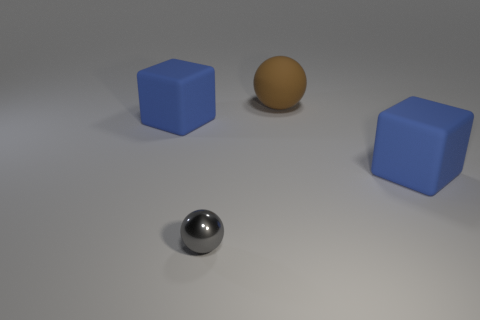How many other objects are the same size as the shiny object?
Provide a succinct answer. 0. What number of objects are either big matte objects that are behind the metallic sphere or tiny metal spheres that are to the left of the big ball?
Give a very brief answer. 4. What number of tiny gray metal things are the same shape as the brown object?
Provide a succinct answer. 1. What material is the object that is both left of the brown rubber ball and behind the gray ball?
Provide a succinct answer. Rubber. There is a large brown matte sphere; what number of small shiny spheres are behind it?
Ensure brevity in your answer.  0. How many brown matte spheres are there?
Give a very brief answer. 1. There is a blue block that is to the right of the large blue matte thing left of the small gray metal thing; are there any gray metal balls in front of it?
Your response must be concise. Yes. What is the material of the large thing that is the same shape as the tiny thing?
Make the answer very short. Rubber. There is a ball to the right of the small gray thing; what is its color?
Give a very brief answer. Brown. How big is the brown rubber ball?
Keep it short and to the point. Large. 